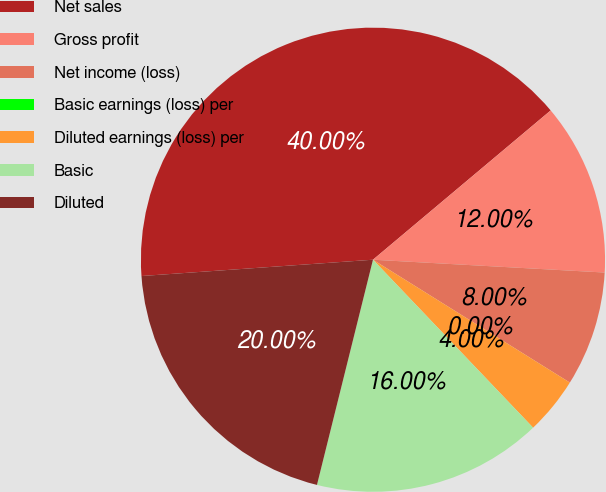Convert chart. <chart><loc_0><loc_0><loc_500><loc_500><pie_chart><fcel>Net sales<fcel>Gross profit<fcel>Net income (loss)<fcel>Basic earnings (loss) per<fcel>Diluted earnings (loss) per<fcel>Basic<fcel>Diluted<nl><fcel>40.0%<fcel>12.0%<fcel>8.0%<fcel>0.0%<fcel>4.0%<fcel>16.0%<fcel>20.0%<nl></chart> 